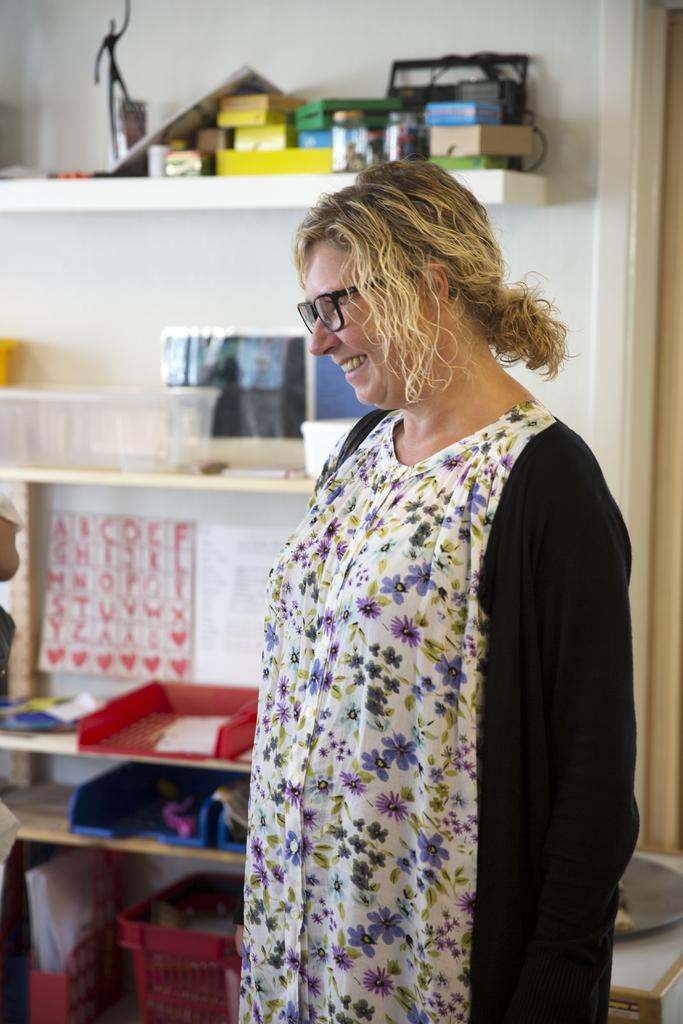Who is present in the image? There is a woman in the image. What is the woman wearing? The woman is wearing spectacles. What is the woman's facial expression? The woman is smiling. What can be seen on the rock in the image? There is a container on the rock. What is inside the container? There are things inside the container. How many fingers does the net have in the image? There is no net present in the image, so it is not possible to determine the number of fingers it might have. 